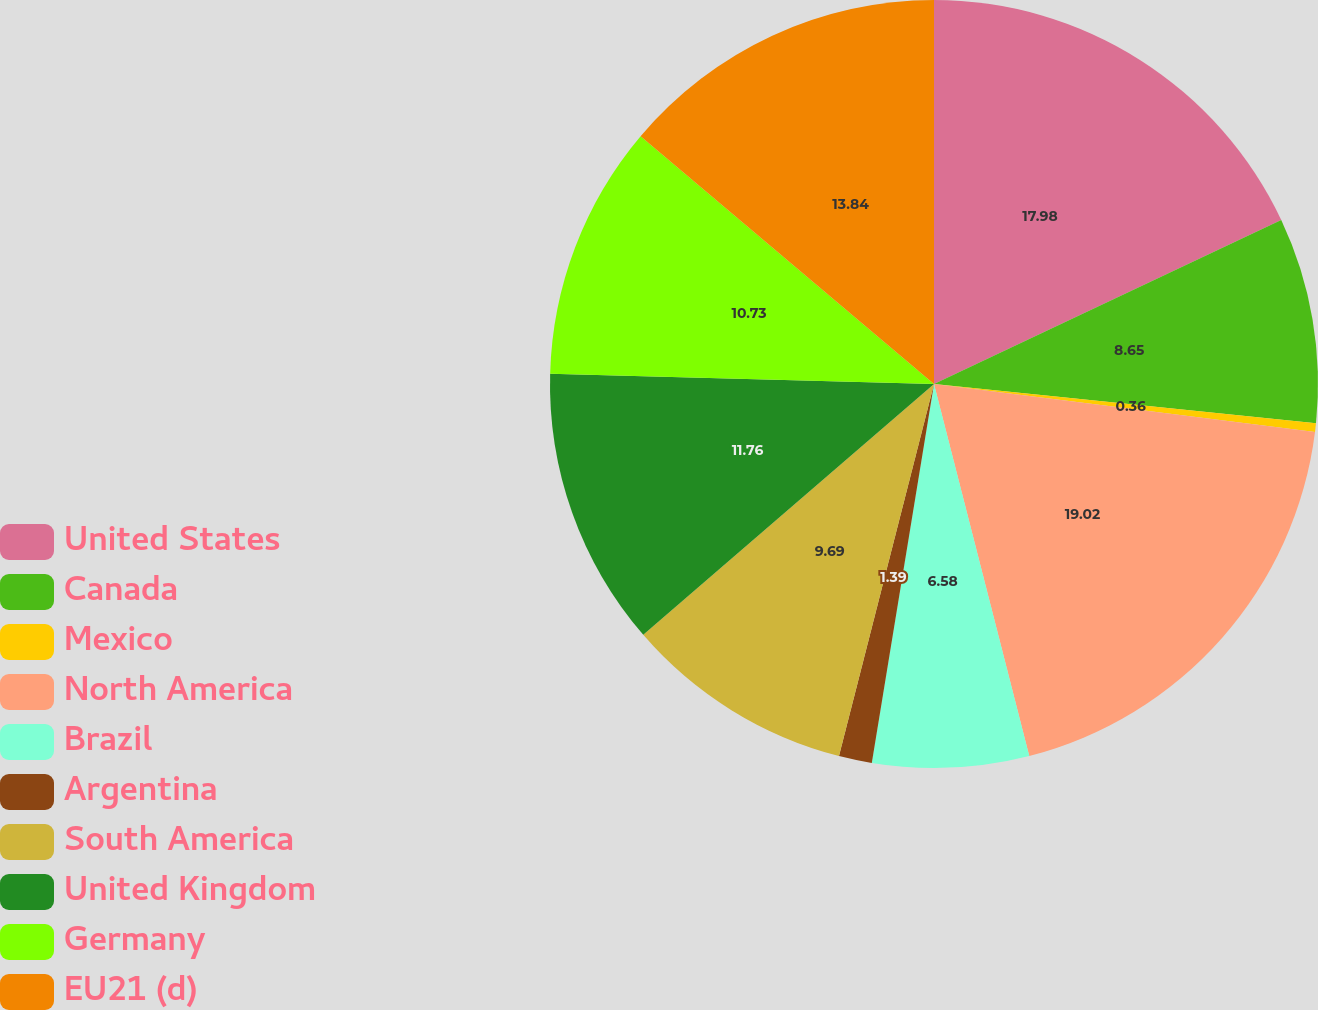<chart> <loc_0><loc_0><loc_500><loc_500><pie_chart><fcel>United States<fcel>Canada<fcel>Mexico<fcel>North America<fcel>Brazil<fcel>Argentina<fcel>South America<fcel>United Kingdom<fcel>Germany<fcel>EU21 (d)<nl><fcel>17.98%<fcel>8.65%<fcel>0.36%<fcel>19.02%<fcel>6.58%<fcel>1.39%<fcel>9.69%<fcel>11.76%<fcel>10.73%<fcel>13.84%<nl></chart> 